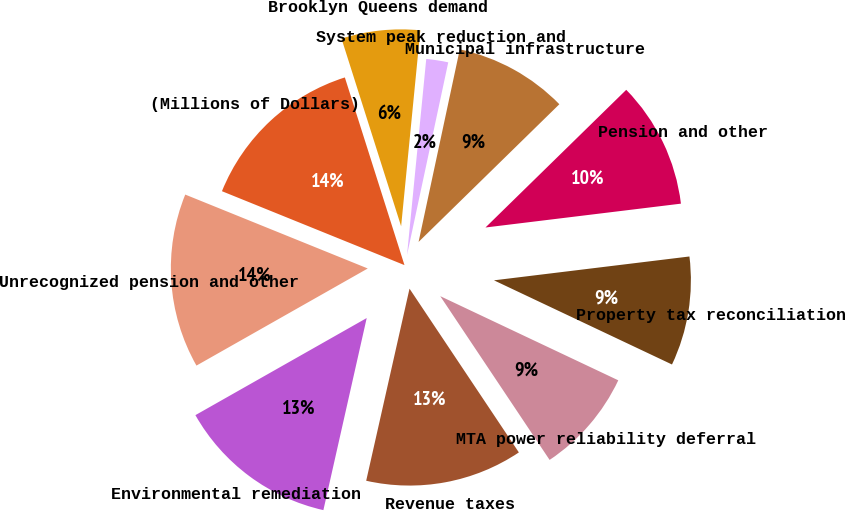Convert chart to OTSL. <chart><loc_0><loc_0><loc_500><loc_500><pie_chart><fcel>(Millions of Dollars)<fcel>Unrecognized pension and other<fcel>Environmental remediation<fcel>Revenue taxes<fcel>MTA power reliability deferral<fcel>Property tax reconciliation<fcel>Pension and other<fcel>Municipal infrastructure<fcel>System peak reduction and<fcel>Brooklyn Queens demand<nl><fcel>13.98%<fcel>14.33%<fcel>13.26%<fcel>12.9%<fcel>8.6%<fcel>8.96%<fcel>10.39%<fcel>9.32%<fcel>1.8%<fcel>6.45%<nl></chart> 